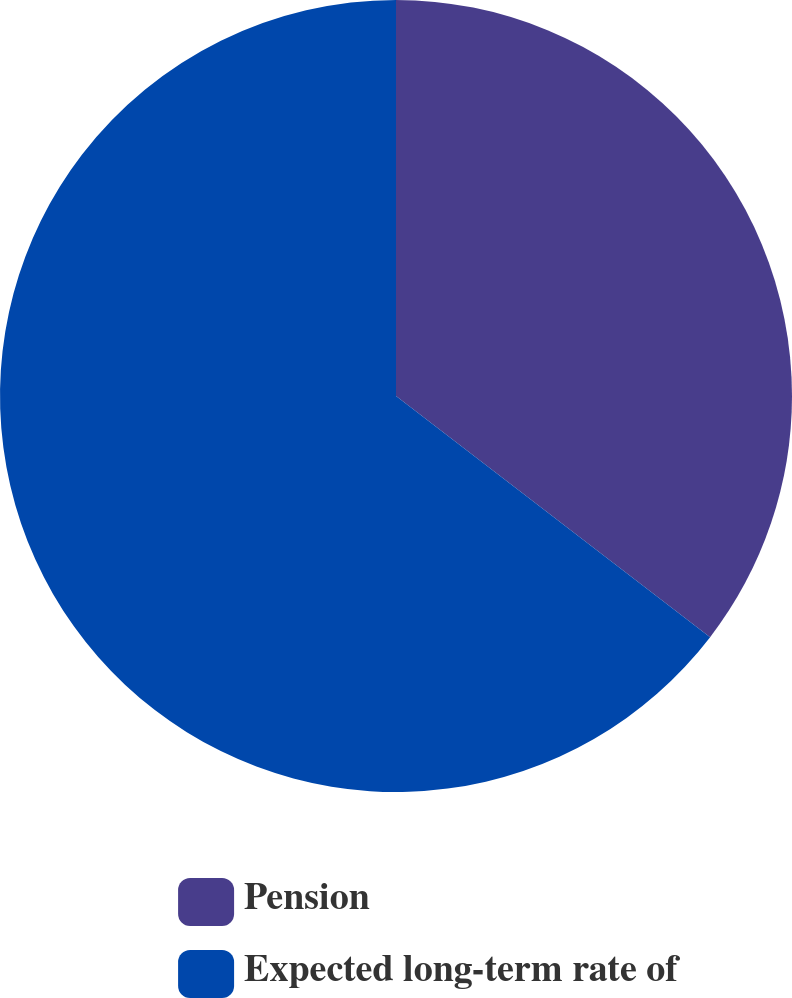<chart> <loc_0><loc_0><loc_500><loc_500><pie_chart><fcel>Pension<fcel>Expected long-term rate of<nl><fcel>35.42%<fcel>64.58%<nl></chart> 